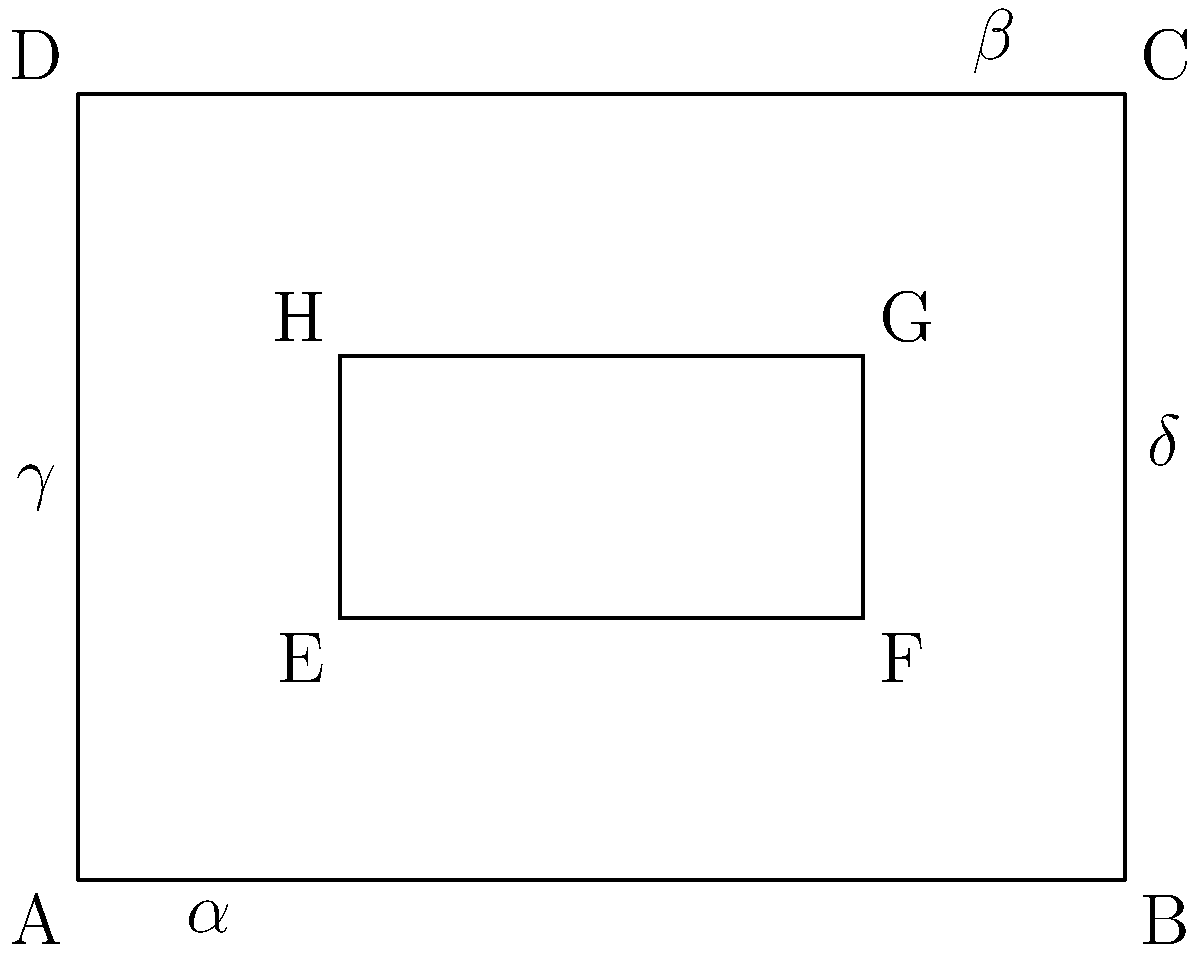In designing a VR headset, you're working on optimizing the field of view (FOV). The diagram represents the FOV, where ABCD is the total visible area and EFGH is the area of highest visual acuity. If angles $\alpha$ and $\beta$ are congruent, and angles $\gamma$ and $\delta$ are congruent, what is the relationship between AE and CG? Let's approach this step-by-step:

1) In a rectangle, opposite angles are congruent. So, $\angle DAB \cong \angle BCD$ and $\angle ABC \cong \angle CDA$.

2) We're given that $\alpha \cong \beta$. This means $\angle DAB \cong \angle BCD$.

3) Similarly, we're told that $\gamma \cong \delta$. This means $\angle ADE \cong \angle BCG$.

4) In a rectangle, adjacent angles are supplementary. So, $\angle DAB + \angle ADE = 90°$ and $\angle BCD + \angle BCG = 90°$.

5) Since $\angle DAB \cong \angle BCD$ and $\angle ADE \cong \angle BCG$, we can conclude that $\triangle ADE \cong \triangle CGB$ (by the AAS congruence criterion).

6) When two triangles are congruent, their corresponding sides are equal in length.

7) AE is a side in $\triangle ADE$, and CG is the corresponding side in $\triangle CGB$.

Therefore, AE = CG.
Answer: AE = CG 